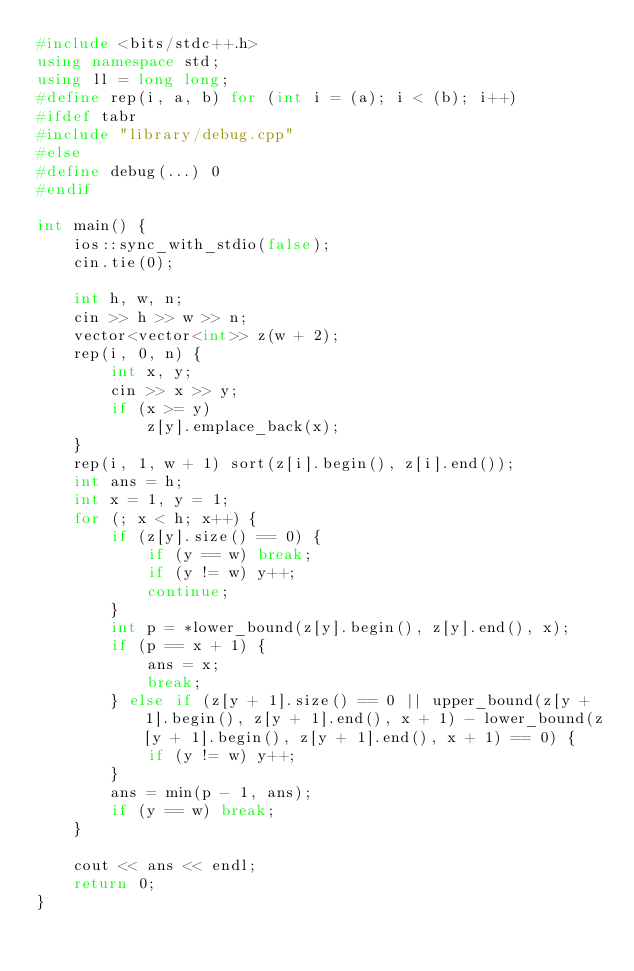Convert code to text. <code><loc_0><loc_0><loc_500><loc_500><_C++_>#include <bits/stdc++.h>
using namespace std;
using ll = long long;
#define rep(i, a, b) for (int i = (a); i < (b); i++)
#ifdef tabr
#include "library/debug.cpp"
#else
#define debug(...) 0
#endif

int main() {
    ios::sync_with_stdio(false);
    cin.tie(0);

    int h, w, n;
    cin >> h >> w >> n;
    vector<vector<int>> z(w + 2);
    rep(i, 0, n) {
        int x, y;
        cin >> x >> y;
        if (x >= y)
            z[y].emplace_back(x);
    }
    rep(i, 1, w + 1) sort(z[i].begin(), z[i].end());
    int ans = h;
    int x = 1, y = 1;
    for (; x < h; x++) {
        if (z[y].size() == 0) {
            if (y == w) break;
            if (y != w) y++;
            continue;
        }
        int p = *lower_bound(z[y].begin(), z[y].end(), x);
        if (p == x + 1) {
            ans = x;
            break;
        } else if (z[y + 1].size() == 0 || upper_bound(z[y + 1].begin(), z[y + 1].end(), x + 1) - lower_bound(z[y + 1].begin(), z[y + 1].end(), x + 1) == 0) {
            if (y != w) y++;
        }
        ans = min(p - 1, ans);
        if (y == w) break;
    }

    cout << ans << endl;
    return 0;
}</code> 